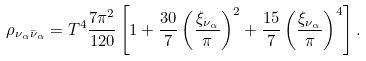<formula> <loc_0><loc_0><loc_500><loc_500>\rho _ { \nu _ { \alpha } \bar { \nu } _ { \alpha } } = T ^ { 4 } \frac { 7 \pi ^ { 2 } } { 1 2 0 } \left [ 1 + \frac { 3 0 } { 7 } \left ( \frac { \xi _ { \nu _ { \alpha } } } { \pi } \right ) ^ { 2 } + \frac { 1 5 } { 7 } \left ( \frac { \xi _ { \nu _ { \alpha } } } { \pi } \right ) ^ { 4 } \right ] .</formula> 